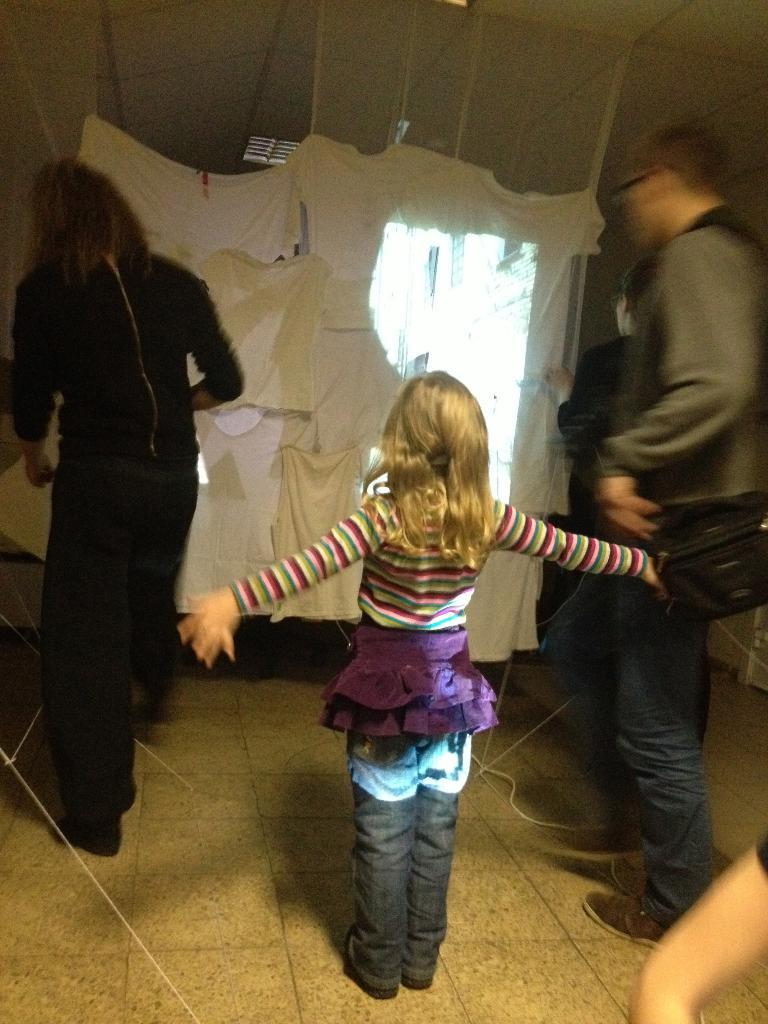How many people are present in the image? There are two people in the image. What are the two people doing in the image? The two people are adjusting a cloth. Can you describe the girl in the image? The girl is standing in front of the cloth and stretching her arms wide. What type of match is the girl participating in the image? There is no match or competition present in the image; it features two people adjusting a cloth with a girl standing in front of it. 